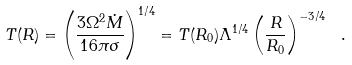<formula> <loc_0><loc_0><loc_500><loc_500>T ( R ) = \left ( \frac { 3 \Omega ^ { 2 } \dot { M } } { 1 6 \pi \sigma } \right ) ^ { 1 / 4 } = T ( R _ { 0 } ) \Lambda ^ { 1 / 4 } \left ( \frac { R } { R _ { 0 } } \right ) ^ { - 3 / 4 } \ .</formula> 